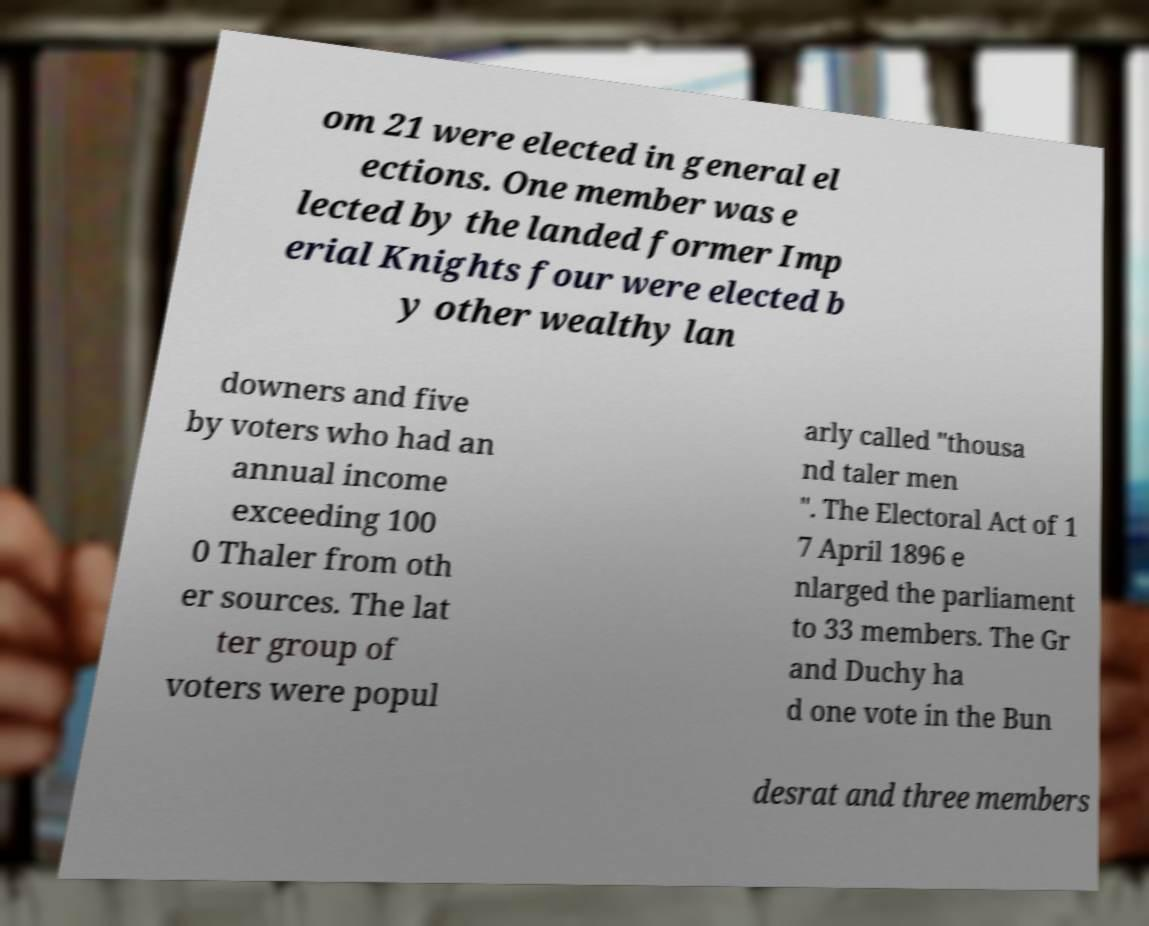What messages or text are displayed in this image? I need them in a readable, typed format. om 21 were elected in general el ections. One member was e lected by the landed former Imp erial Knights four were elected b y other wealthy lan downers and five by voters who had an annual income exceeding 100 0 Thaler from oth er sources. The lat ter group of voters were popul arly called "thousa nd taler men ". The Electoral Act of 1 7 April 1896 e nlarged the parliament to 33 members. The Gr and Duchy ha d one vote in the Bun desrat and three members 